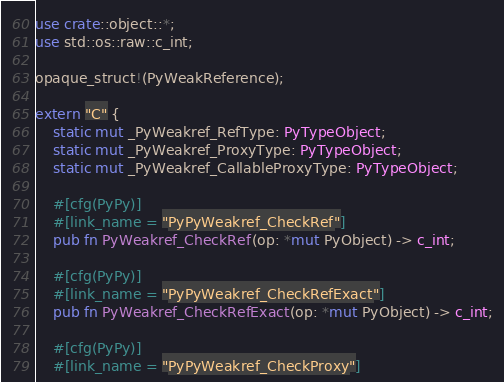Convert code to text. <code><loc_0><loc_0><loc_500><loc_500><_Rust_>use crate::object::*;
use std::os::raw::c_int;

opaque_struct!(PyWeakReference);

extern "C" {
    static mut _PyWeakref_RefType: PyTypeObject;
    static mut _PyWeakref_ProxyType: PyTypeObject;
    static mut _PyWeakref_CallableProxyType: PyTypeObject;

    #[cfg(PyPy)]
    #[link_name = "PyPyWeakref_CheckRef"]
    pub fn PyWeakref_CheckRef(op: *mut PyObject) -> c_int;

    #[cfg(PyPy)]
    #[link_name = "PyPyWeakref_CheckRefExact"]
    pub fn PyWeakref_CheckRefExact(op: *mut PyObject) -> c_int;

    #[cfg(PyPy)]
    #[link_name = "PyPyWeakref_CheckProxy"]</code> 